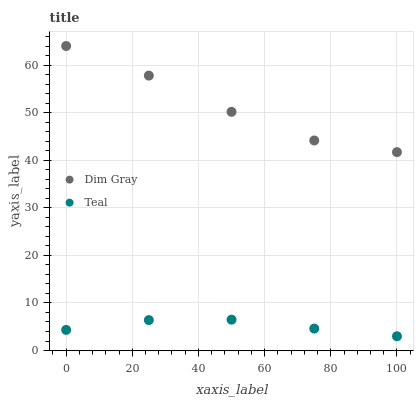Does Teal have the minimum area under the curve?
Answer yes or no. Yes. Does Dim Gray have the maximum area under the curve?
Answer yes or no. Yes. Does Teal have the maximum area under the curve?
Answer yes or no. No. Is Teal the smoothest?
Answer yes or no. Yes. Is Dim Gray the roughest?
Answer yes or no. Yes. Is Teal the roughest?
Answer yes or no. No. Does Teal have the lowest value?
Answer yes or no. Yes. Does Dim Gray have the highest value?
Answer yes or no. Yes. Does Teal have the highest value?
Answer yes or no. No. Is Teal less than Dim Gray?
Answer yes or no. Yes. Is Dim Gray greater than Teal?
Answer yes or no. Yes. Does Teal intersect Dim Gray?
Answer yes or no. No. 